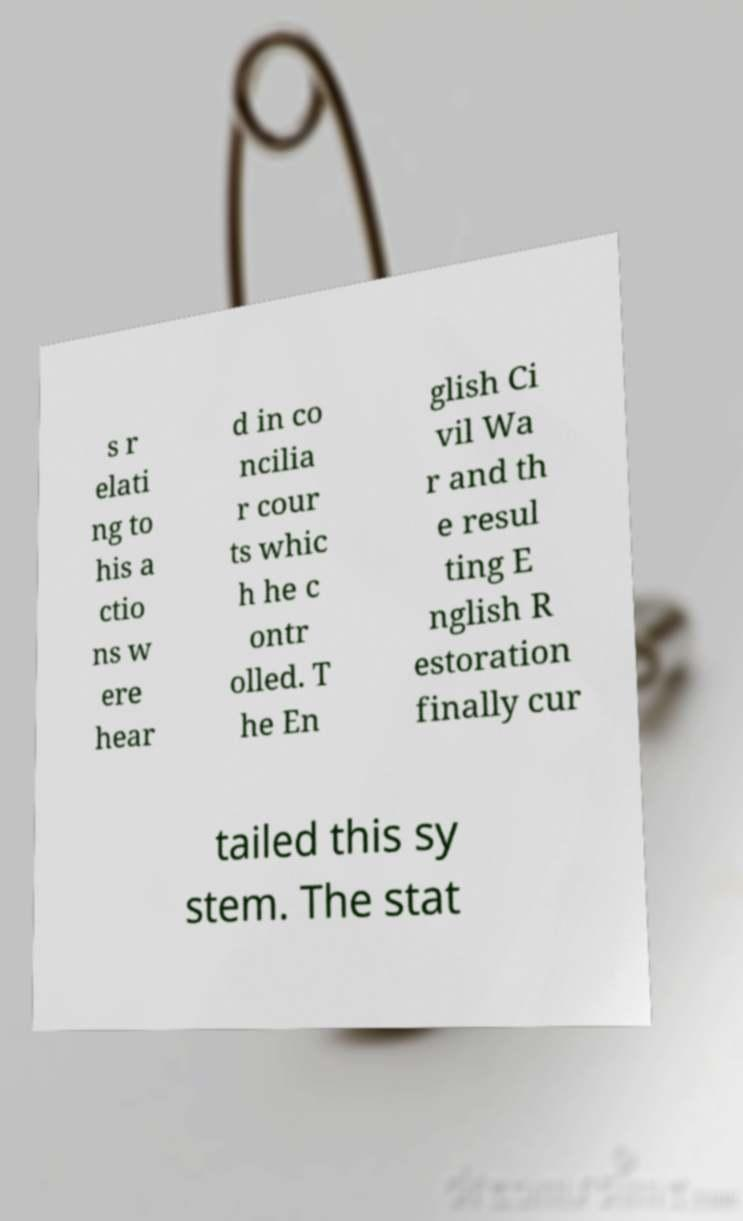Please identify and transcribe the text found in this image. s r elati ng to his a ctio ns w ere hear d in co ncilia r cour ts whic h he c ontr olled. T he En glish Ci vil Wa r and th e resul ting E nglish R estoration finally cur tailed this sy stem. The stat 